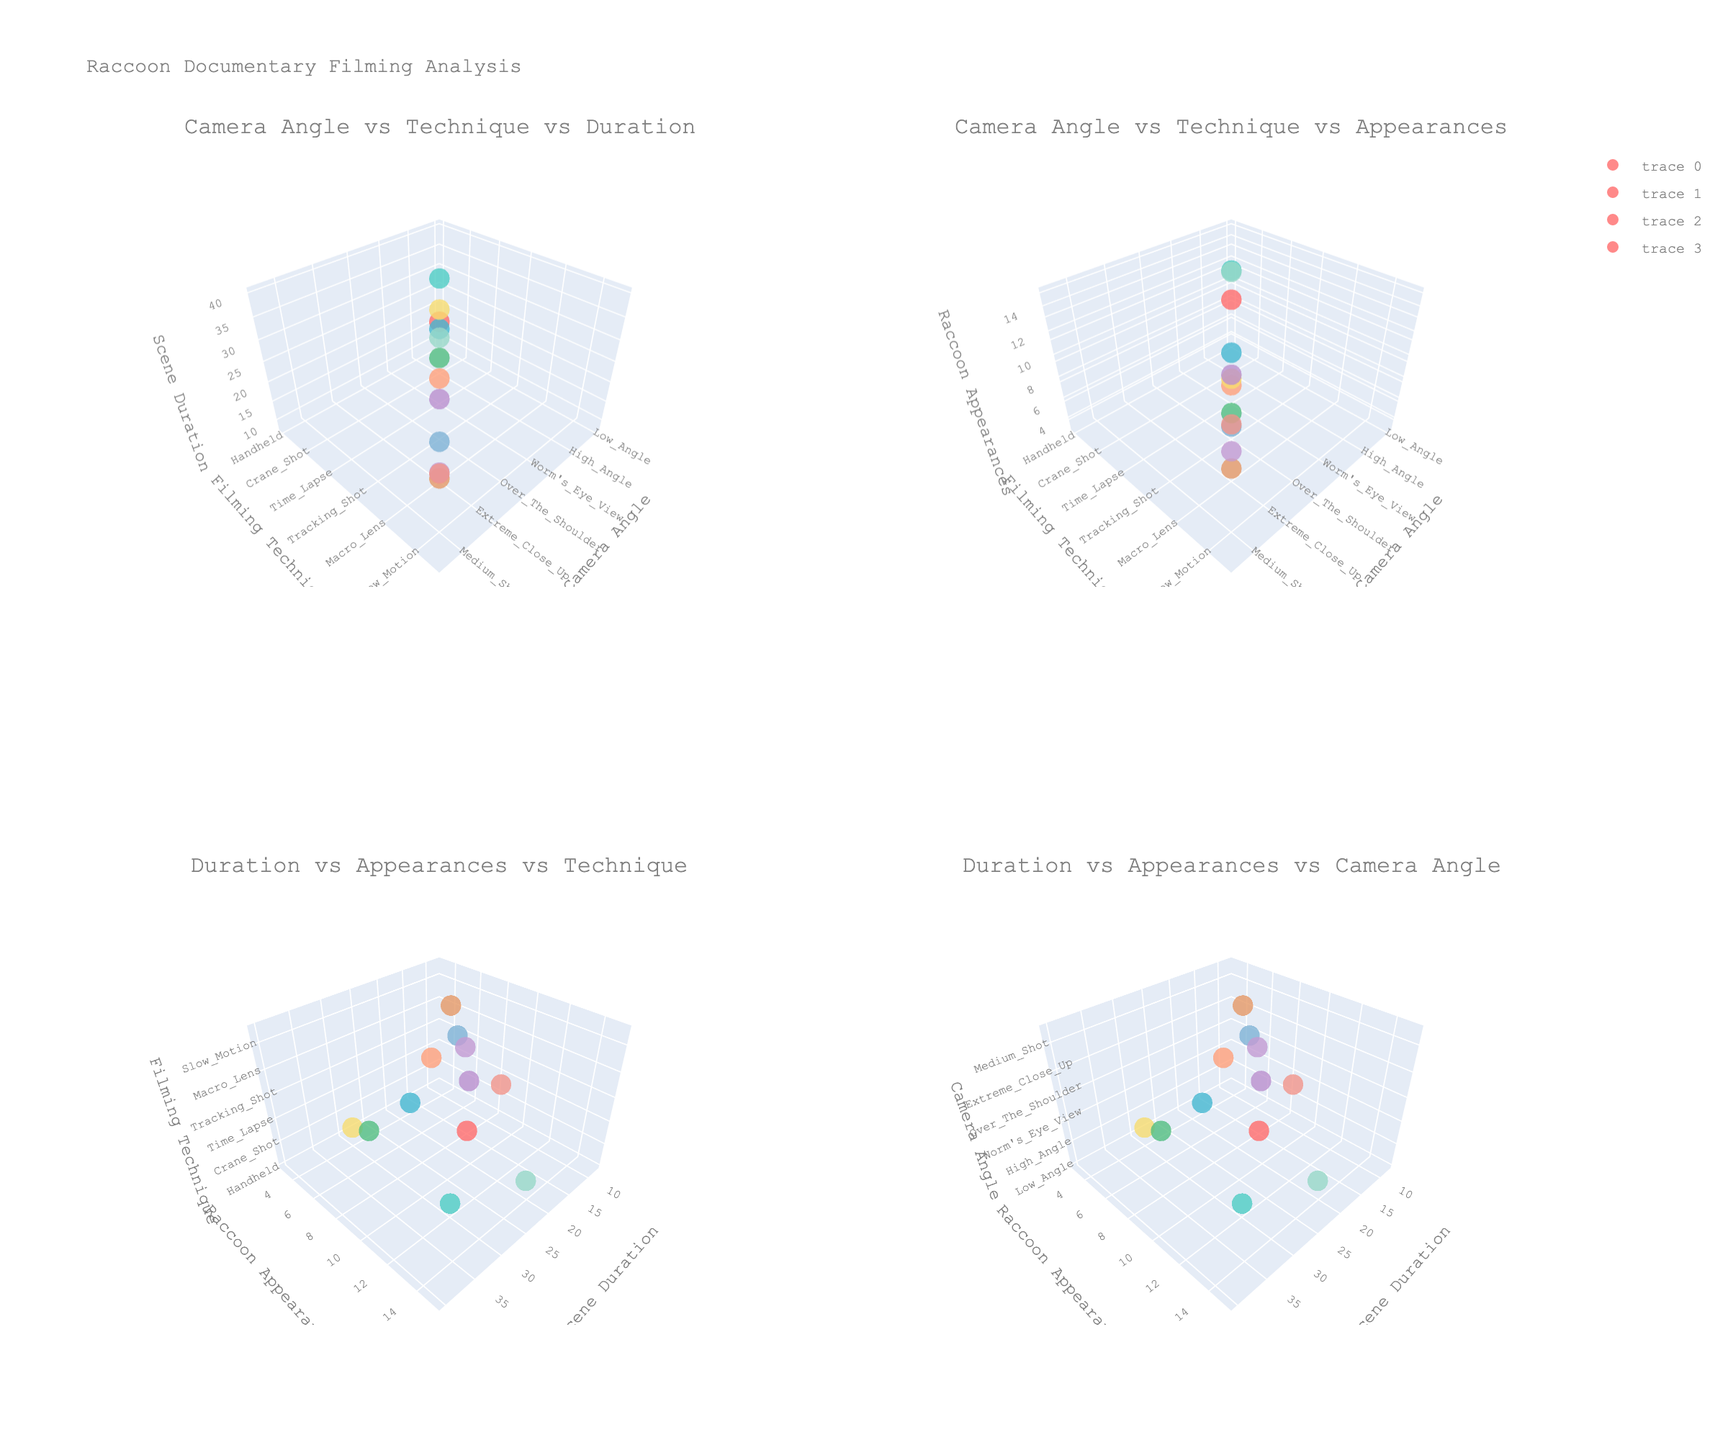Which filming technique is associated with the longest scene duration? In the subplot "Duration vs Appearances vs Technique," identify the highest z-axis value (scene duration) and note the corresponding filming technique.
Answer: Long take Which camera angle is paired with the filming technique "Handheld"? Refer to the subplot "Camera Angle vs Technique vs Duration," locate 'Handheld' on the y-axis and identify the corresponding camera angle on the x-axis.
Answer: Low Angle How many raccoon appearances are there for scenes shot with a crane shot technique? In the subplot "Camera Angle vs Technique vs Appearances," locate 'Crane Shot' on the y-axis and track the corresponding raccoon appearance value on the z-axis.
Answer: 5 Compare the durations of scenes shot with "Time Lapse" vs. "Night Vision." Which one is longer? In the subplot "Duration vs Appearances vs Technique," identify the z-axis values corresponding to 'Time Lapse' and 'Night Vision' on the y-axis, then compare these values.
Answer: Time Lapse What is the relationship between "Scene Duration" and "Raccoon Appearances" for the filming technique "Drone Shot"? Refer to the subplot "Duration vs Appearances vs Technique," locate 'Drone Shot' on the z-axis, and examine the x and y-axis values for that point.
Answer: Scene Duration: 35, Raccoon Appearances: 7 What camera angle has the highest number of raccoon appearances? In the subplot "Duration vs Appearances vs Camera Angle," identify the highest y-axis value (raccoon appearances) and note the corresponding x-axis value (camera angle).
Answer: Worm's Eye View Which subplot shows the relationship between "Camera Angle," "Filming Technique," and "Scene Duration"? Look at the subplot titles and identify which one includes "Camera Angle," "Filming Technique," and "Scene Duration."
Answer: Camera Angle vs Technique vs Duration How does the number of raccoon appearances change with longer scene durations? In both plots involving scene duration ("Duration vs Appearances vs Technique" and "Duration vs Appearances vs Camera Angle"), observe the trend along the x-axis (scene duration) and the y-axis (raccoon appearances).
Answer: Generally increases Which camera angle has the longest scene duration for the "Tracked Shot" technique? Check the subplot "Duration vs Appearances vs Camera Angle," find 'Tracking Shot' on the z-axis, then track the longest x-axis value (scene duration) for it and identify its corresponding x-axis value (camera angle).
Answer: Over The Shoulder 